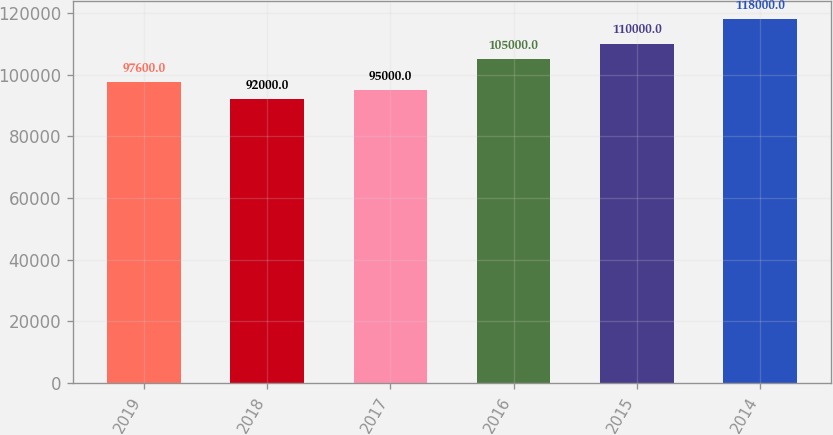<chart> <loc_0><loc_0><loc_500><loc_500><bar_chart><fcel>2019<fcel>2018<fcel>2017<fcel>2016<fcel>2015<fcel>2014<nl><fcel>97600<fcel>92000<fcel>95000<fcel>105000<fcel>110000<fcel>118000<nl></chart> 